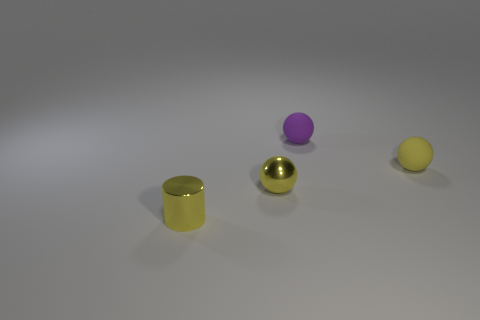There is a purple thing that is the same shape as the small yellow rubber object; what is its material?
Keep it short and to the point. Rubber. Are there an equal number of small yellow metal spheres that are left of the tiny purple matte thing and small metal things in front of the tiny metal sphere?
Keep it short and to the point. Yes. Is the material of the small purple object the same as the tiny yellow cylinder?
Your answer should be very brief. No. What number of yellow things are small matte things or cylinders?
Offer a very short reply. 2. What number of other tiny matte objects are the same shape as the small yellow matte thing?
Your answer should be compact. 1. What material is the small purple ball?
Offer a terse response. Rubber. Is the number of small spheres left of the small purple sphere the same as the number of cyan blocks?
Offer a terse response. No. There is a yellow shiny thing that is the same size as the shiny sphere; what shape is it?
Ensure brevity in your answer.  Cylinder. There is a tiny rubber sphere that is left of the tiny yellow rubber sphere; are there any tiny yellow spheres in front of it?
Give a very brief answer. Yes. How many large things are rubber objects or yellow matte things?
Provide a succinct answer. 0. 